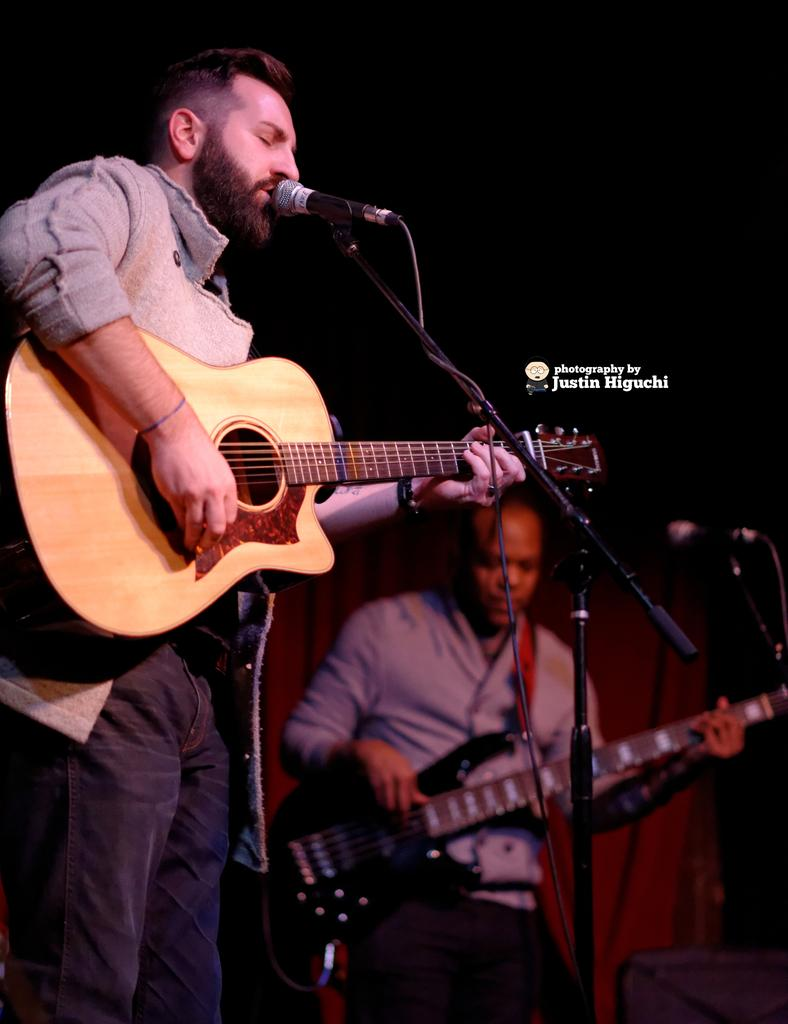How many people are in the image? There are two persons in the image. What are the people doing in the image? One person is playing a guitar, and the other person is playing a guitar and singing on a microphone. What is the tendency of the nation in the image? There is no reference to a nation or any tendencies in the image, as it features two people playing musical instruments and singing. 